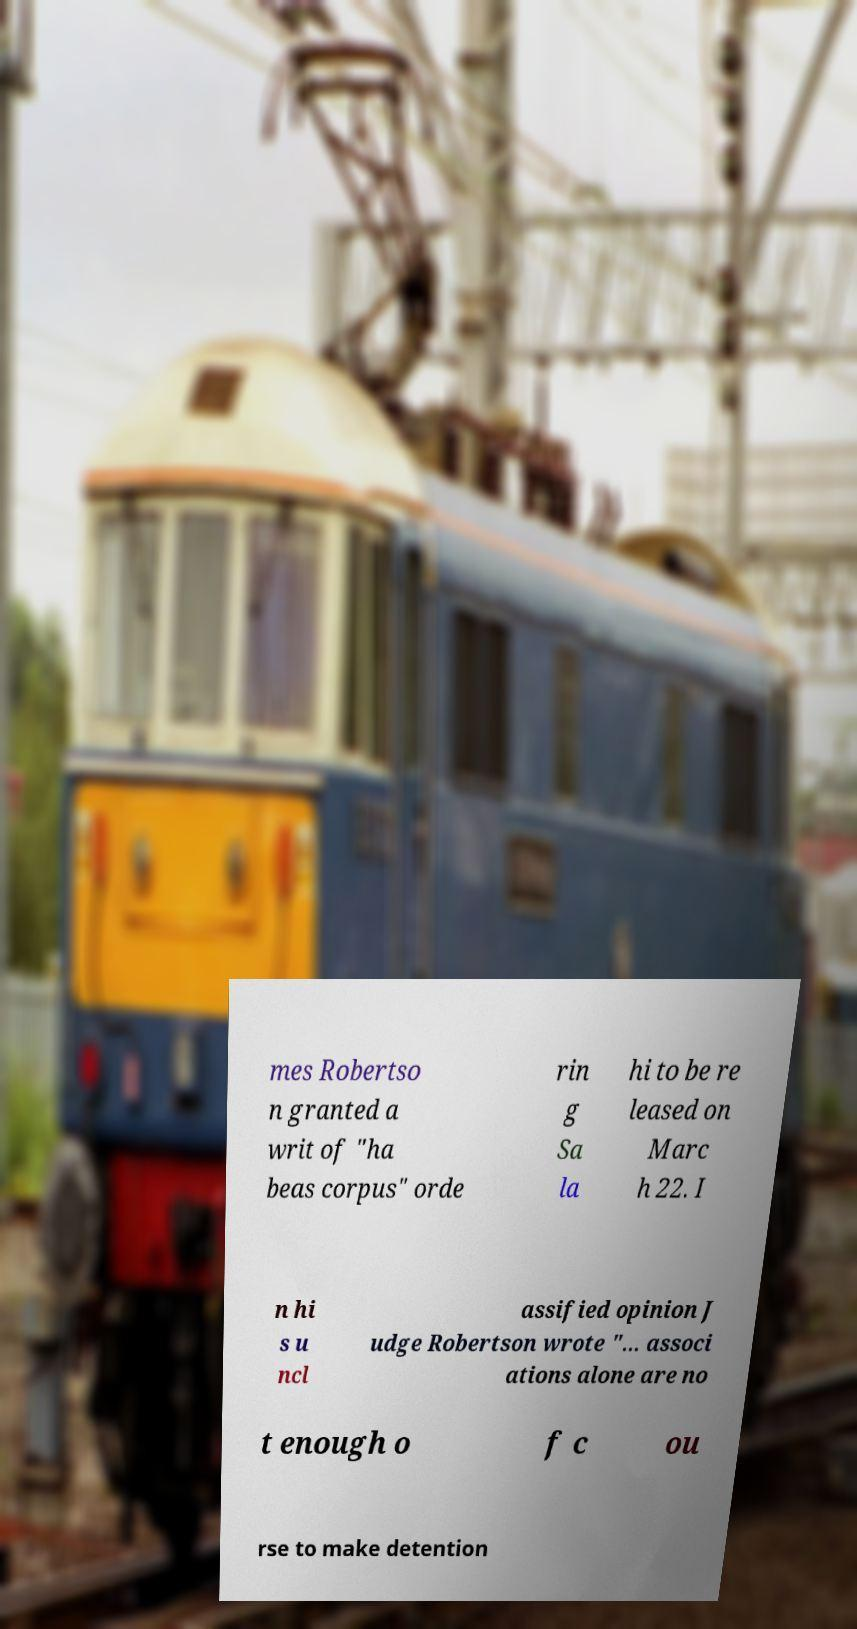Could you assist in decoding the text presented in this image and type it out clearly? mes Robertso n granted a writ of "ha beas corpus" orde rin g Sa la hi to be re leased on Marc h 22. I n hi s u ncl assified opinion J udge Robertson wrote "... associ ations alone are no t enough o f c ou rse to make detention 